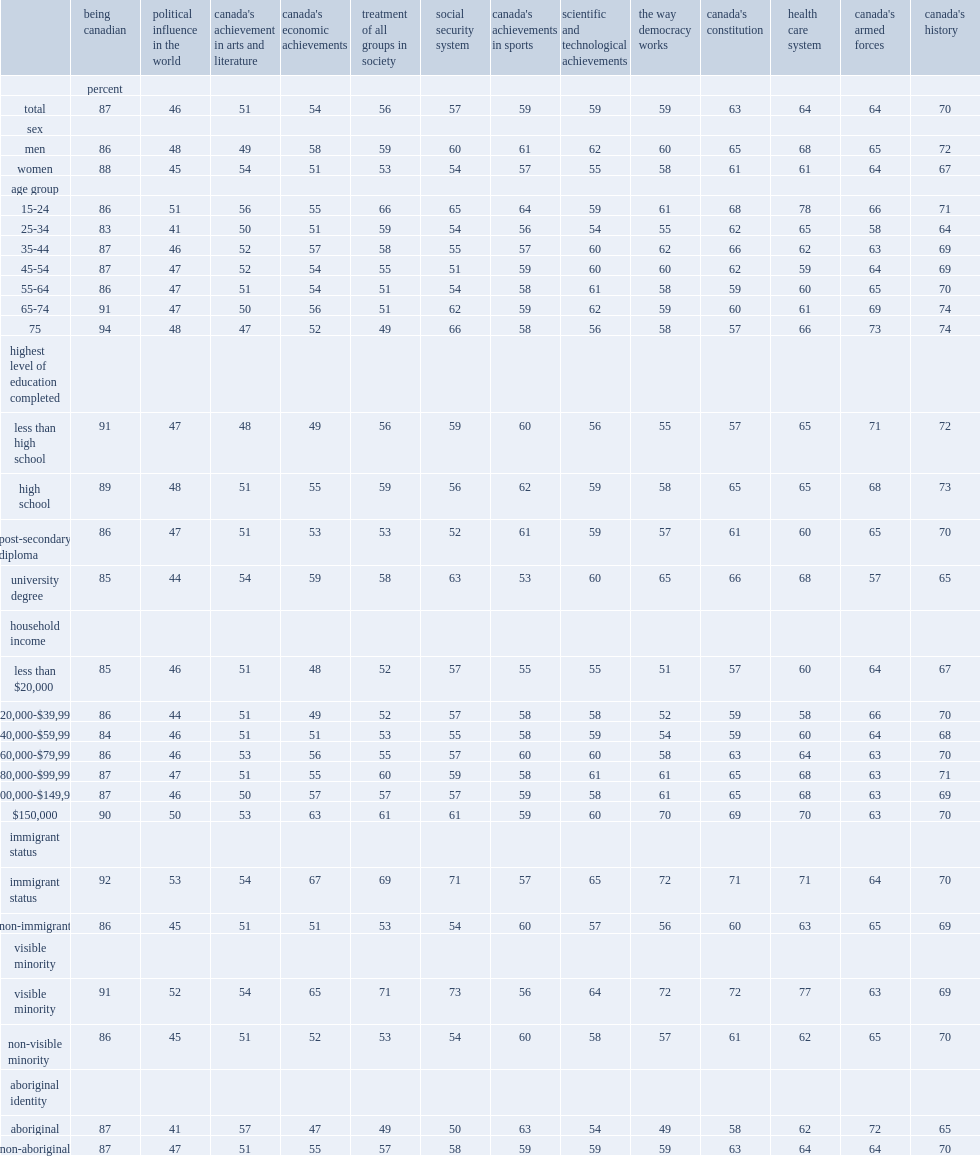What percent of canadians with less than a high school education expressed pride in canadian economic achievements? 49.0. What percent of canadians with an income less than $20,000 had pride in canadian democracy? 51.0. What percent of visible minorities had reported pride in the treatment of all groups in society? 71.0. Which group of people has much more positive terms regarding to the social security system? visible minorities or non-visible minorities? Visible minority. 